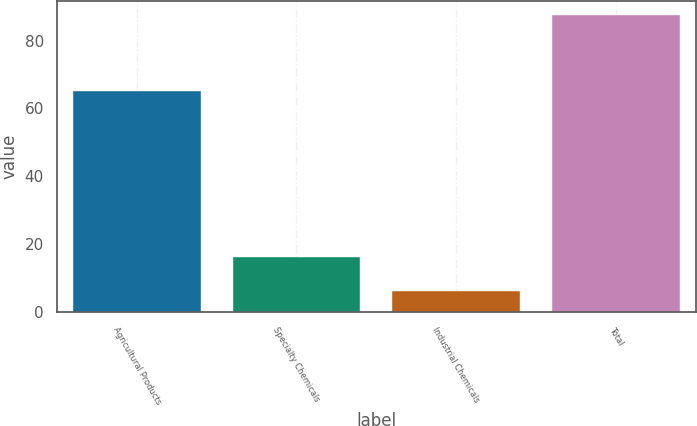<chart> <loc_0><loc_0><loc_500><loc_500><bar_chart><fcel>Agricultural Products<fcel>Specialty Chemicals<fcel>Industrial Chemicals<fcel>Total<nl><fcel>65.1<fcel>16.1<fcel>6.2<fcel>87.4<nl></chart> 